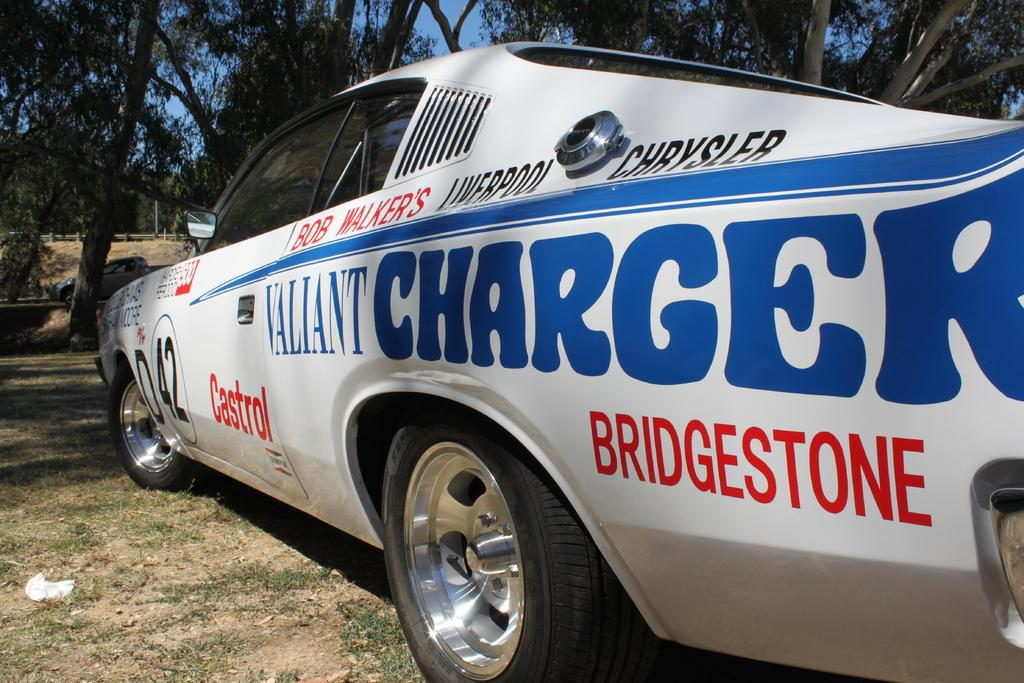What is the main subject of the image? There is a car in the image with text on it. What can be seen in the background of the image? There are trees and the sky visible in the image. What type of terrain is present in the image? There is grass on the ground in the image. Are there any other vehicles in the image? Yes, there is another vehicle in the background of the image. Can you see a hole in the car's windshield in the image? There is no hole visible in the car's windshield in the image. Is there a mitten hanging from the car's rearview mirror in the image? There is no mitten present in the image. 